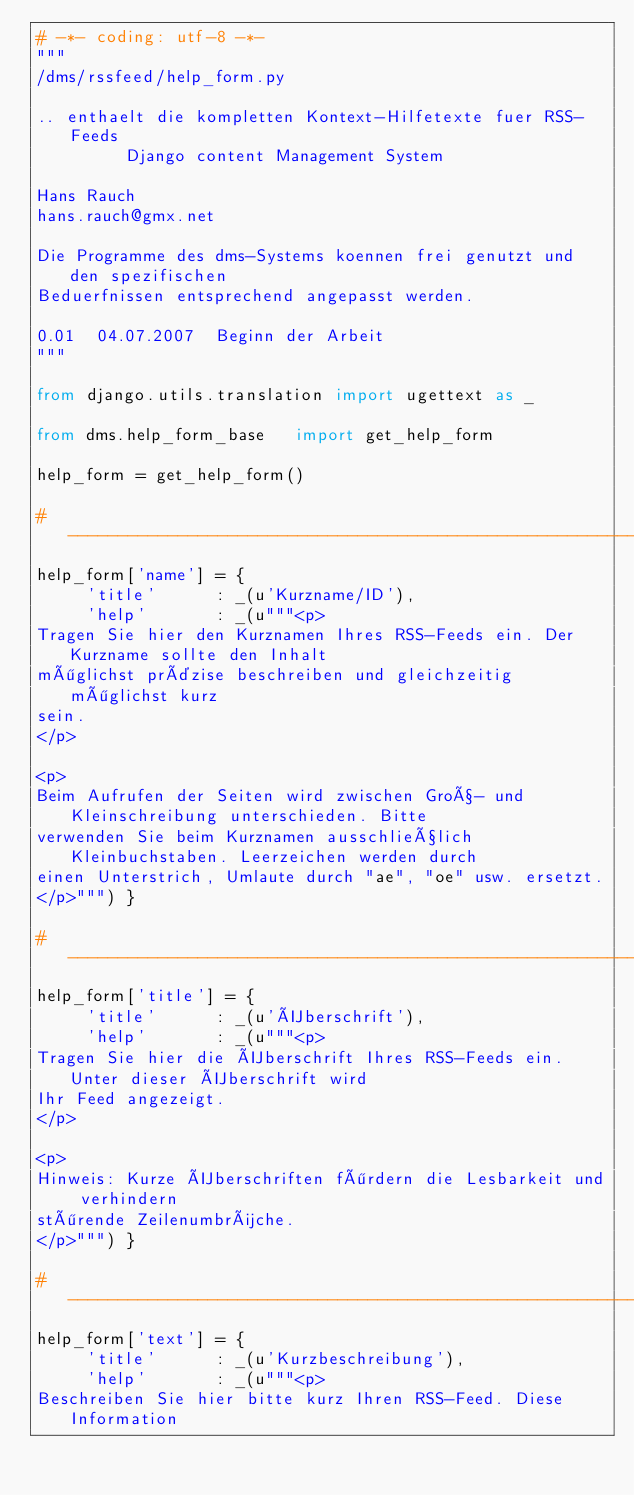Convert code to text. <code><loc_0><loc_0><loc_500><loc_500><_Python_># -*- coding: utf-8 -*-
"""
/dms/rssfeed/help_form.py

.. enthaelt die kompletten Kontext-Hilfetexte fuer RSS-Feeds
         Django content Management System

Hans Rauch
hans.rauch@gmx.net

Die Programme des dms-Systems koennen frei genutzt und den spezifischen
Beduerfnissen entsprechend angepasst werden.

0.01  04.07.2007  Beginn der Arbeit
"""

from django.utils.translation import ugettext as _

from dms.help_form_base   import get_help_form

help_form = get_help_form()

# ----------------------------------------------------------------
help_form['name'] = {
     'title'      : _(u'Kurzname/ID'),
     'help'       : _(u"""<p>
Tragen Sie hier den Kurznamen Ihres RSS-Feeds ein. Der Kurzname sollte den Inhalt
möglichst präzise beschreiben und gleichzeitig möglichst kurz
sein.
</p>

<p>
Beim Aufrufen der Seiten wird zwischen Groß- und Kleinschreibung unterschieden. Bitte
verwenden Sie beim Kurznamen ausschließlich Kleinbuchstaben. Leerzeichen werden durch
einen Unterstrich, Umlaute durch "ae", "oe" usw. ersetzt.
</p>""") }

# ----------------------------------------------------------------
help_form['title'] = {
     'title'      : _(u'Überschrift'), 
     'help'       : _(u"""<p>
Tragen Sie hier die Überschrift Ihres RSS-Feeds ein. Unter dieser Überschrift wird 
Ihr Feed angezeigt.
</p>

<p>
Hinweis: Kurze Überschriften fördern die Lesbarkeit und verhindern 
störende Zeilenumbrüche.
</p>""") }

# ----------------------------------------------------------------
help_form['text'] = {
     'title'      : _(u'Kurzbeschreibung'),
     'help'       : _(u"""<p>
Beschreiben Sie hier bitte kurz Ihren RSS-Feed. Diese Information</code> 